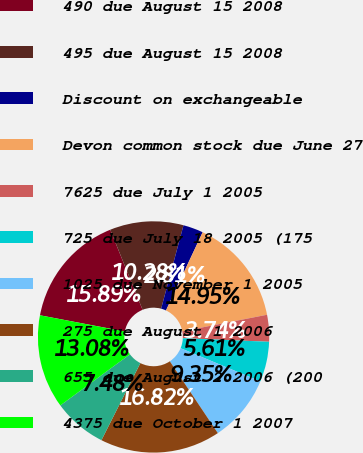Convert chart to OTSL. <chart><loc_0><loc_0><loc_500><loc_500><pie_chart><fcel>490 due August 15 2008<fcel>495 due August 15 2008<fcel>Discount on exchangeable<fcel>Devon common stock due June 27<fcel>7625 due July 1 2005<fcel>725 due July 18 2005 (175<fcel>1025 due November 1 2005<fcel>275 due August 1 2006<fcel>655 due August 2 2006 (200<fcel>4375 due October 1 2007<nl><fcel>15.89%<fcel>10.28%<fcel>2.81%<fcel>14.95%<fcel>3.74%<fcel>5.61%<fcel>9.35%<fcel>16.82%<fcel>7.48%<fcel>13.08%<nl></chart> 